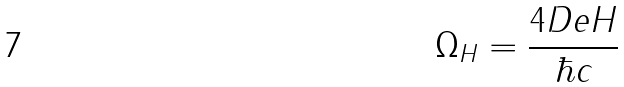<formula> <loc_0><loc_0><loc_500><loc_500>\Omega _ { H } = \frac { 4 D e H } { \hbar { c } }</formula> 